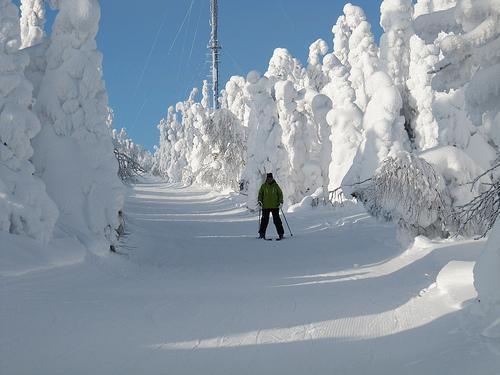How many people are in the picture?
Give a very brief answer. 1. 